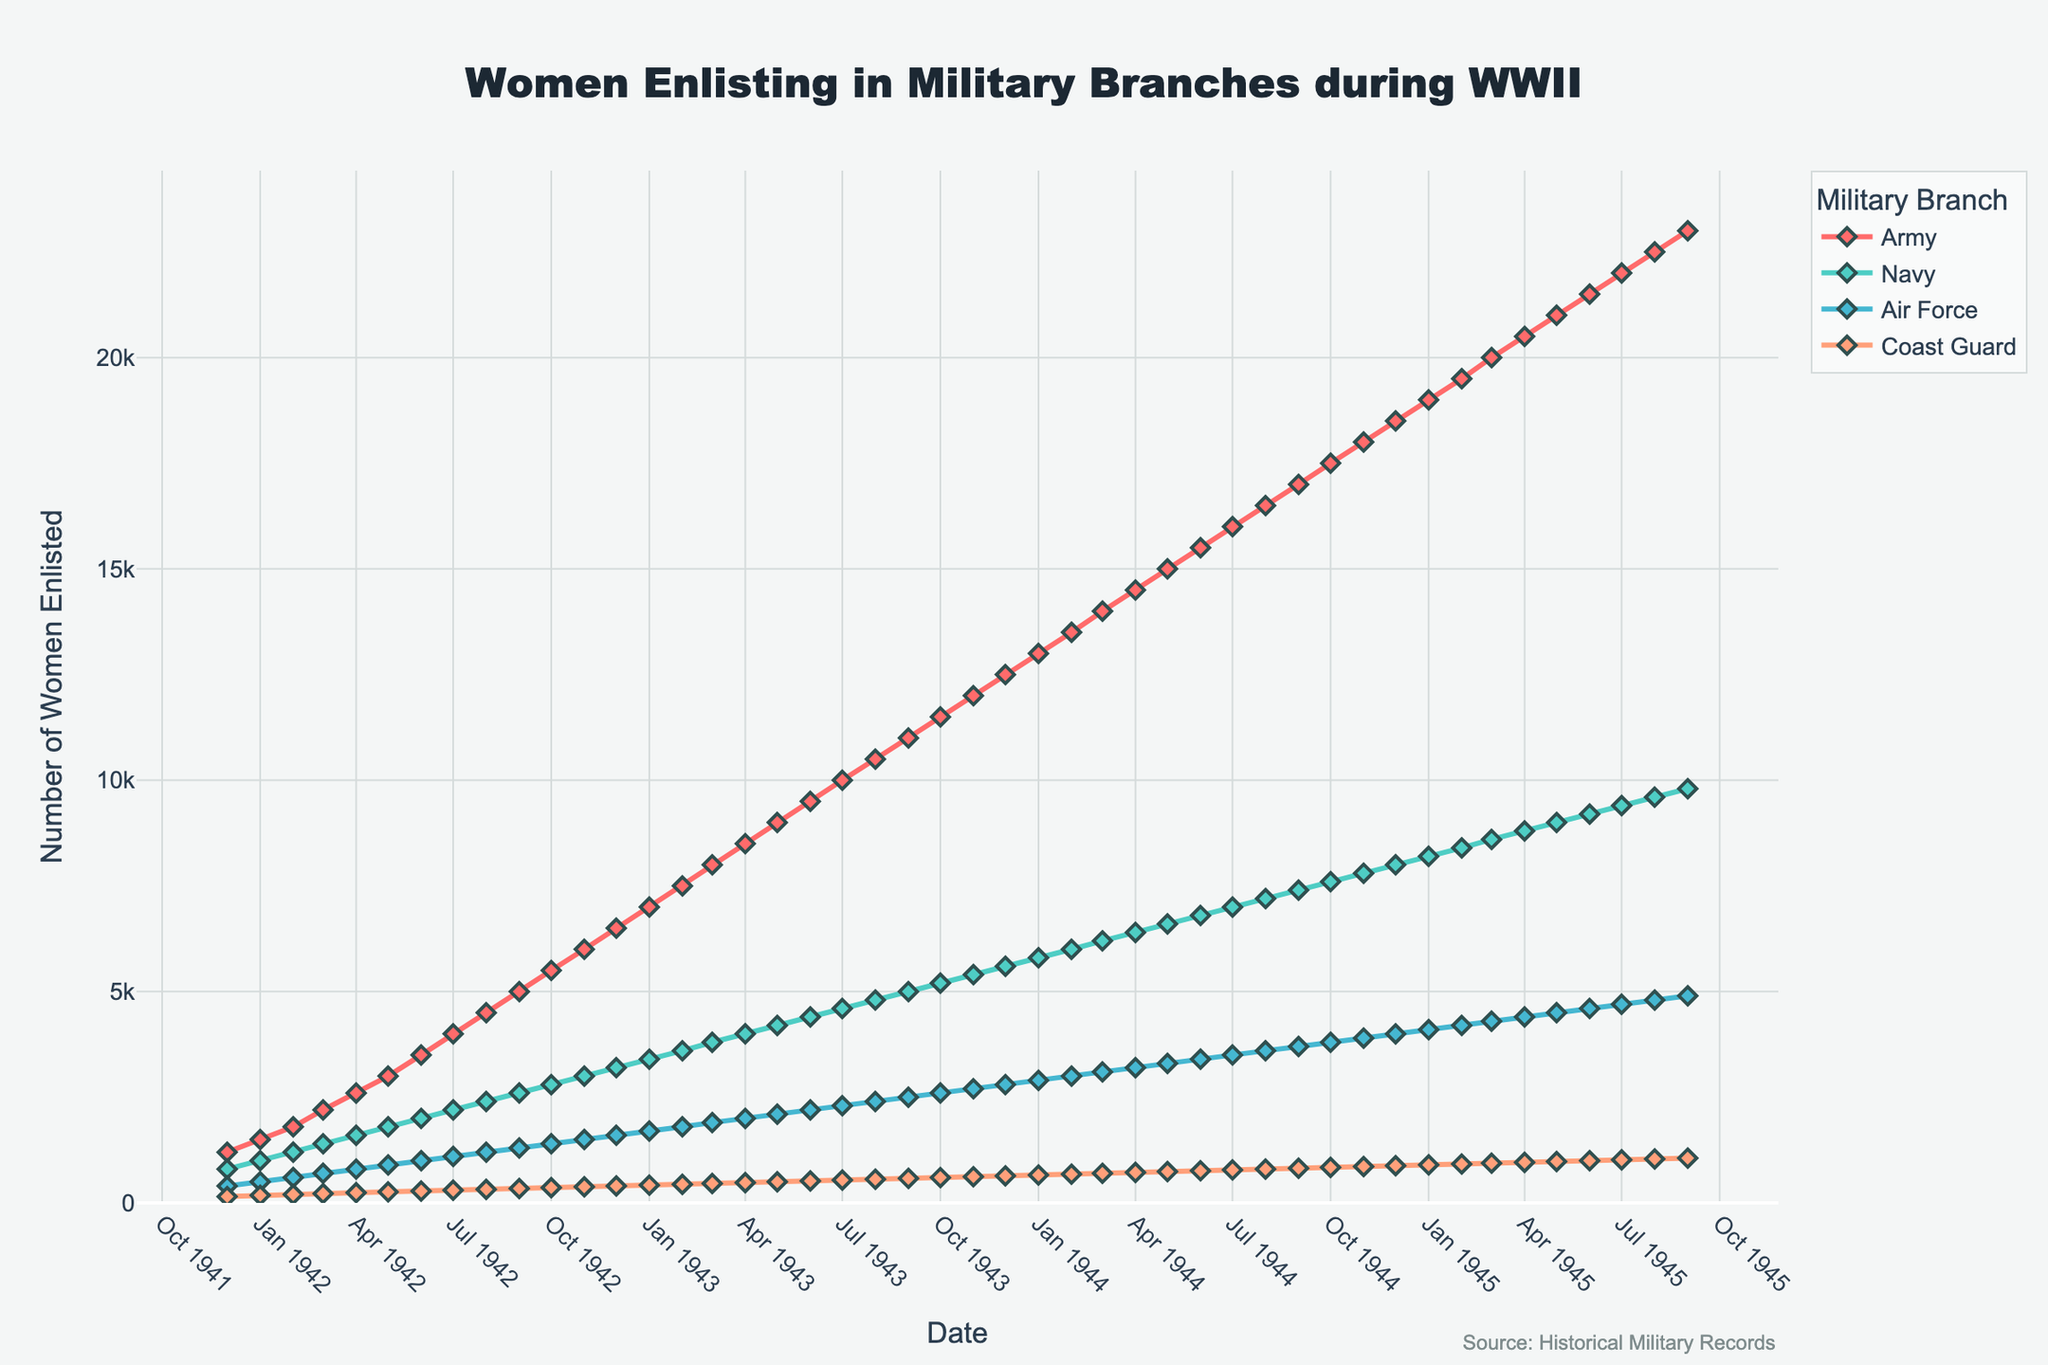What was the trend in the number of women enlisting in the Army from the beginning of the graph to the end? To observe the trend in the number of women enlisting in the Army, we follow the path of the red line representing the Army. From December 1941 to September 1945, the number of women enlisting in the Army continuously increased, rising steadily each month.
Answer: Increasing trend In which month and year did the Navy first reach 5,000 women enlistees? To find the month and year when the Navy first reached 5,000 enlistees, look for the point on the light blue line corresponding to 5,000 on the y-axis. This occurs in September 1943.
Answer: September 1943 Which military branch had the slowest growth in the number of women enlistees throughout WWII? To determine which branch had the slowest growth, compare the slopes of the lines representing each branch. The Coast Guard (orange line) shows the flattest slope, indicating the slowest growth in the number of women enlistees.
Answer: Coast Guard How many women enlisted in total in the Air Force and Coast Guard by December 1943? To find the total number of women enlisted in the Air Force and Coast Guard by December 1943, sum the values for these branches in that month: Air Force (2800) + Coast Guard (640). The total is 2800 + 640 = 3440.
Answer: 3440 When did the Army reach 10,000 enlistees, and how much later did the Navy reach the same number? The Army reached 10,000 enlistees in July 1943. The Navy reached 10,000 enlistees approximately in August 1944. The Navy reached this mark 13 months later than the Army.
Answer: 13 months later Which month in 1945 saw the highest enlistee count for the Coast Guard, and what was the number? To find the highest monthly enlistee count for the Coast Guard in 1945, check the peak of the orange line in 1945. In September 1945, the Coast Guard had the highest number, 1060 enlistees.
Answer: September 1945, 1060 How does the enlistment trend for the Air Force compare to the Navy in 1944? Comparing the green (Air Force) and light blue (Navy) lines throughout 1944, the Air Force shows a consistently increasing trend but at a slower rate compared to the Navy. Both lines have an upward trajectory, but the Navy's growth is steeper.
Answer: Air Force slower, Navy faster What was the difference in women enlistees between the Army and the Navy in January 1943? To find the difference in women enlistees between the Army and the Navy in January 1943, subtract the Navy's count from the Army's count: Army (7000) - Navy (3400). The difference is 7000 - 3400 = 3600.
Answer: 3600 How did the number of women enlisting in the Coast Guard change from February 1942 to February 1943? To find the change, subtract the number of Coast Guard enlistees in February 1942 from the number in February 1943: 440 - 200. The change is 440 - 200 = 240.
Answer: Increased by 240 